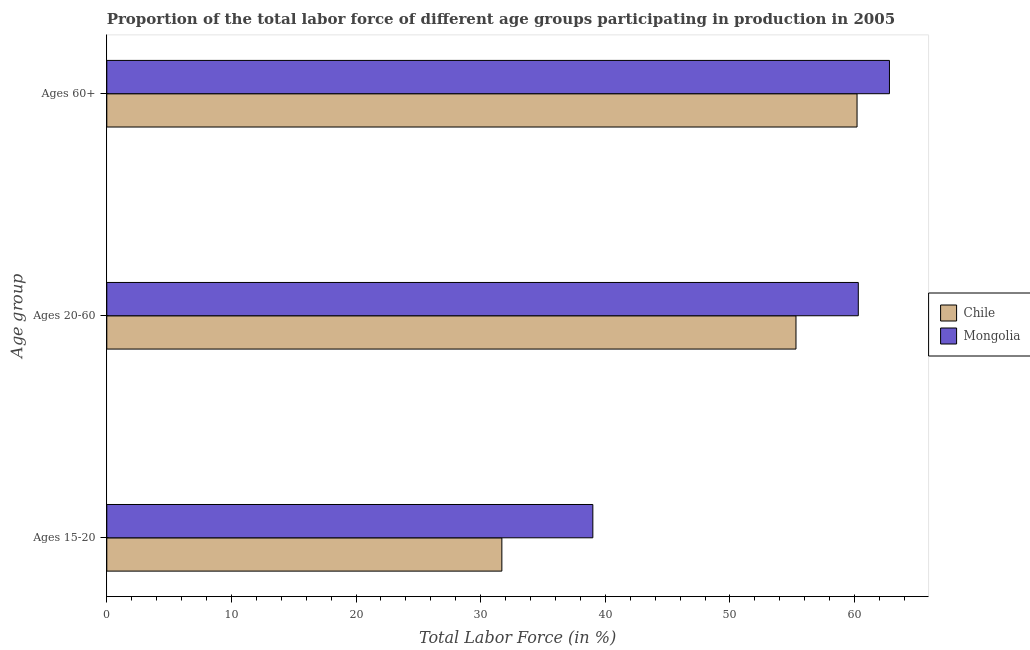How many bars are there on the 1st tick from the top?
Provide a short and direct response. 2. What is the label of the 3rd group of bars from the top?
Your response must be concise. Ages 15-20. What is the percentage of labor force within the age group 15-20 in Chile?
Offer a terse response. 31.7. Across all countries, what is the minimum percentage of labor force above age 60?
Offer a terse response. 60.2. In which country was the percentage of labor force within the age group 15-20 maximum?
Make the answer very short. Mongolia. In which country was the percentage of labor force within the age group 20-60 minimum?
Make the answer very short. Chile. What is the total percentage of labor force above age 60 in the graph?
Ensure brevity in your answer.  123. What is the difference between the percentage of labor force above age 60 in Mongolia and the percentage of labor force within the age group 15-20 in Chile?
Keep it short and to the point. 31.1. What is the average percentage of labor force within the age group 15-20 per country?
Give a very brief answer. 35.35. What is the difference between the percentage of labor force within the age group 20-60 and percentage of labor force within the age group 15-20 in Chile?
Make the answer very short. 23.6. What is the ratio of the percentage of labor force within the age group 20-60 in Chile to that in Mongolia?
Provide a short and direct response. 0.92. What is the difference between the highest and the lowest percentage of labor force above age 60?
Make the answer very short. 2.6. What does the 1st bar from the top in Ages 20-60 represents?
Offer a very short reply. Mongolia. What does the 2nd bar from the bottom in Ages 60+ represents?
Provide a succinct answer. Mongolia. Is it the case that in every country, the sum of the percentage of labor force within the age group 15-20 and percentage of labor force within the age group 20-60 is greater than the percentage of labor force above age 60?
Your response must be concise. Yes. Are the values on the major ticks of X-axis written in scientific E-notation?
Your response must be concise. No. Does the graph contain any zero values?
Give a very brief answer. No. How many legend labels are there?
Provide a short and direct response. 2. What is the title of the graph?
Offer a very short reply. Proportion of the total labor force of different age groups participating in production in 2005. What is the label or title of the Y-axis?
Provide a succinct answer. Age group. What is the Total Labor Force (in %) in Chile in Ages 15-20?
Ensure brevity in your answer.  31.7. What is the Total Labor Force (in %) of Chile in Ages 20-60?
Your answer should be compact. 55.3. What is the Total Labor Force (in %) in Mongolia in Ages 20-60?
Offer a terse response. 60.3. What is the Total Labor Force (in %) in Chile in Ages 60+?
Provide a succinct answer. 60.2. What is the Total Labor Force (in %) of Mongolia in Ages 60+?
Your response must be concise. 62.8. Across all Age group, what is the maximum Total Labor Force (in %) in Chile?
Ensure brevity in your answer.  60.2. Across all Age group, what is the maximum Total Labor Force (in %) of Mongolia?
Give a very brief answer. 62.8. Across all Age group, what is the minimum Total Labor Force (in %) in Chile?
Keep it short and to the point. 31.7. Across all Age group, what is the minimum Total Labor Force (in %) in Mongolia?
Your answer should be compact. 39. What is the total Total Labor Force (in %) in Chile in the graph?
Your response must be concise. 147.2. What is the total Total Labor Force (in %) in Mongolia in the graph?
Provide a succinct answer. 162.1. What is the difference between the Total Labor Force (in %) in Chile in Ages 15-20 and that in Ages 20-60?
Your response must be concise. -23.6. What is the difference between the Total Labor Force (in %) of Mongolia in Ages 15-20 and that in Ages 20-60?
Provide a succinct answer. -21.3. What is the difference between the Total Labor Force (in %) of Chile in Ages 15-20 and that in Ages 60+?
Provide a short and direct response. -28.5. What is the difference between the Total Labor Force (in %) of Mongolia in Ages 15-20 and that in Ages 60+?
Ensure brevity in your answer.  -23.8. What is the difference between the Total Labor Force (in %) in Mongolia in Ages 20-60 and that in Ages 60+?
Keep it short and to the point. -2.5. What is the difference between the Total Labor Force (in %) of Chile in Ages 15-20 and the Total Labor Force (in %) of Mongolia in Ages 20-60?
Keep it short and to the point. -28.6. What is the difference between the Total Labor Force (in %) of Chile in Ages 15-20 and the Total Labor Force (in %) of Mongolia in Ages 60+?
Make the answer very short. -31.1. What is the average Total Labor Force (in %) of Chile per Age group?
Make the answer very short. 49.07. What is the average Total Labor Force (in %) of Mongolia per Age group?
Keep it short and to the point. 54.03. What is the difference between the Total Labor Force (in %) in Chile and Total Labor Force (in %) in Mongolia in Ages 20-60?
Your response must be concise. -5. What is the difference between the Total Labor Force (in %) in Chile and Total Labor Force (in %) in Mongolia in Ages 60+?
Offer a terse response. -2.6. What is the ratio of the Total Labor Force (in %) in Chile in Ages 15-20 to that in Ages 20-60?
Your answer should be compact. 0.57. What is the ratio of the Total Labor Force (in %) in Mongolia in Ages 15-20 to that in Ages 20-60?
Keep it short and to the point. 0.65. What is the ratio of the Total Labor Force (in %) of Chile in Ages 15-20 to that in Ages 60+?
Your response must be concise. 0.53. What is the ratio of the Total Labor Force (in %) of Mongolia in Ages 15-20 to that in Ages 60+?
Ensure brevity in your answer.  0.62. What is the ratio of the Total Labor Force (in %) of Chile in Ages 20-60 to that in Ages 60+?
Your response must be concise. 0.92. What is the ratio of the Total Labor Force (in %) in Mongolia in Ages 20-60 to that in Ages 60+?
Offer a very short reply. 0.96. What is the difference between the highest and the second highest Total Labor Force (in %) in Chile?
Your answer should be very brief. 4.9. What is the difference between the highest and the lowest Total Labor Force (in %) in Chile?
Ensure brevity in your answer.  28.5. What is the difference between the highest and the lowest Total Labor Force (in %) in Mongolia?
Make the answer very short. 23.8. 